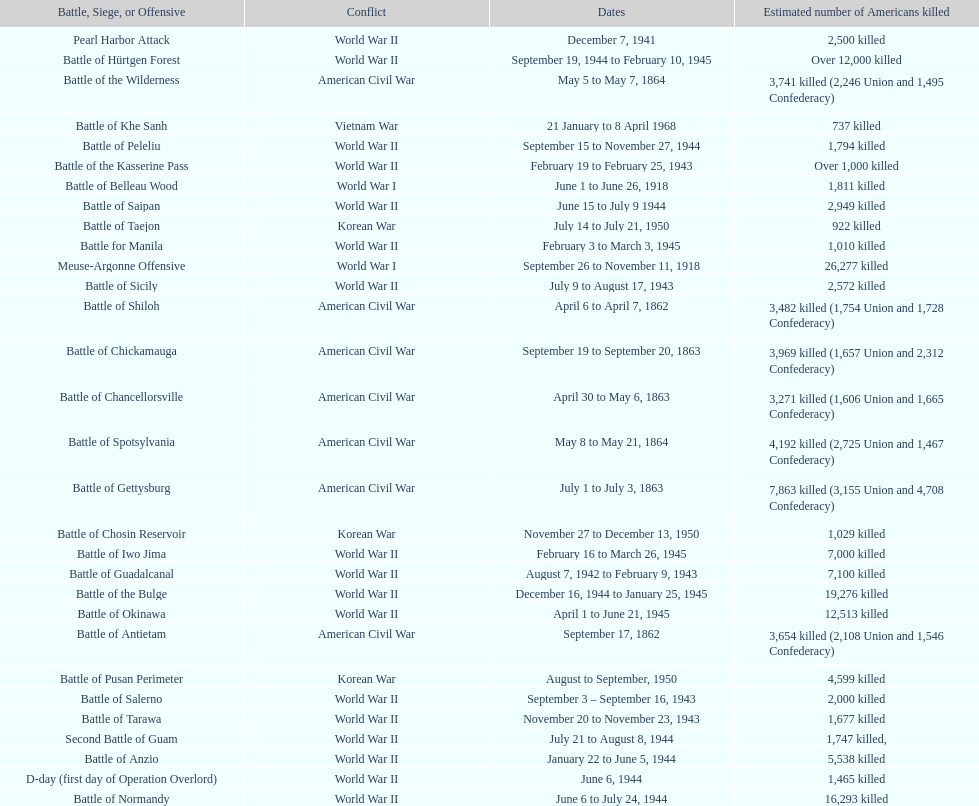How many battles resulted between 3,000 and 4,200 estimated americans killed? 6. 